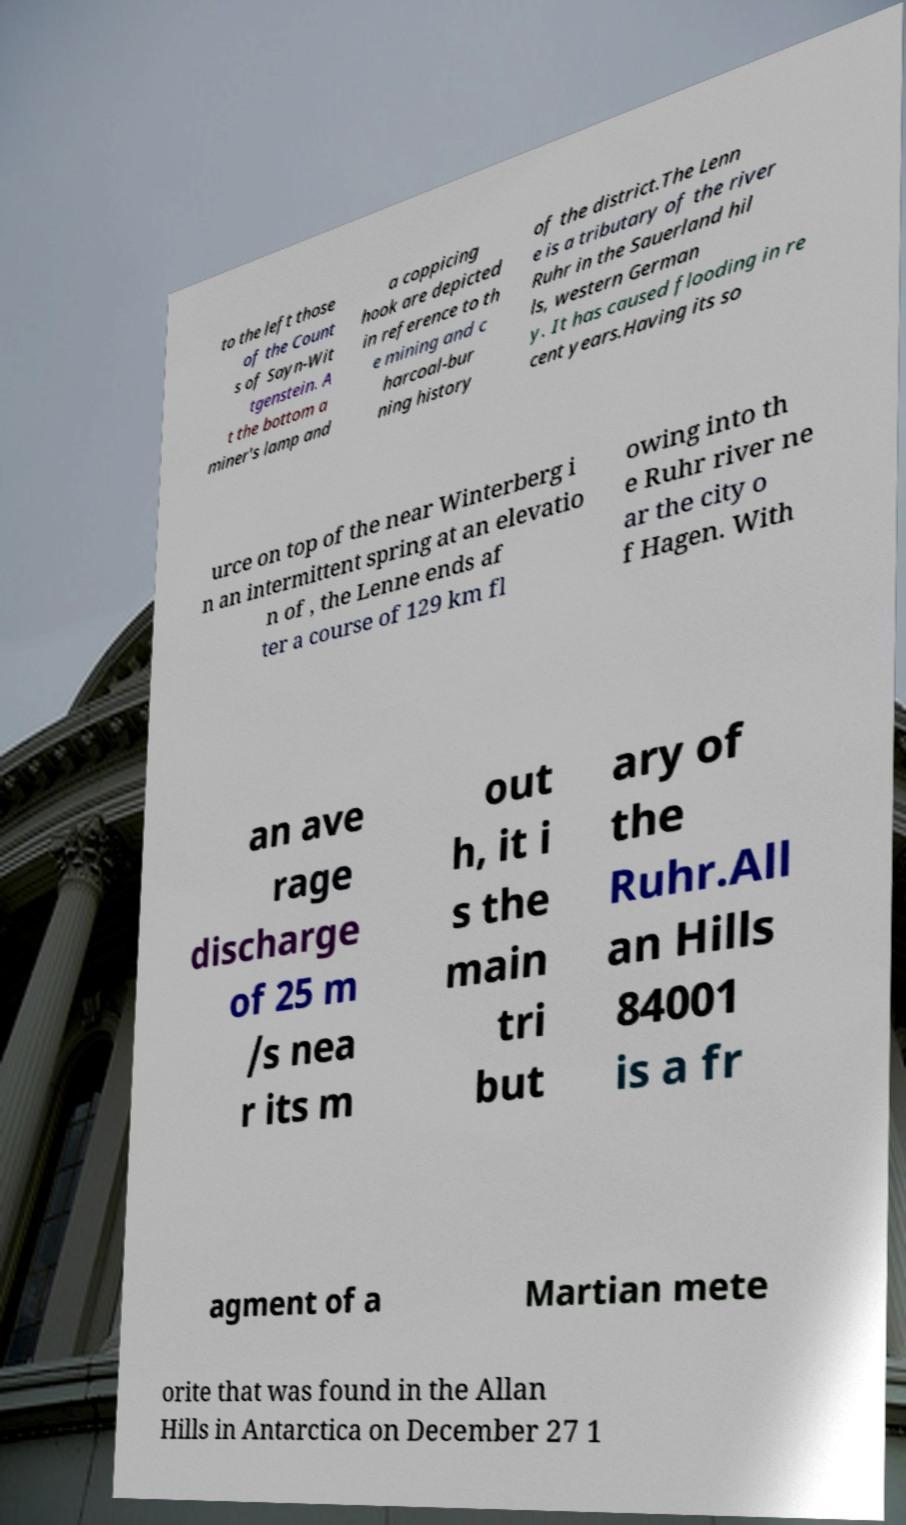There's text embedded in this image that I need extracted. Can you transcribe it verbatim? to the left those of the Count s of Sayn-Wit tgenstein. A t the bottom a miner's lamp and a coppicing hook are depicted in reference to th e mining and c harcoal-bur ning history of the district.The Lenn e is a tributary of the river Ruhr in the Sauerland hil ls, western German y. It has caused flooding in re cent years.Having its so urce on top of the near Winterberg i n an intermittent spring at an elevatio n of , the Lenne ends af ter a course of 129 km fl owing into th e Ruhr river ne ar the city o f Hagen. With an ave rage discharge of 25 m /s nea r its m out h, it i s the main tri but ary of the Ruhr.All an Hills 84001 is a fr agment of a Martian mete orite that was found in the Allan Hills in Antarctica on December 27 1 